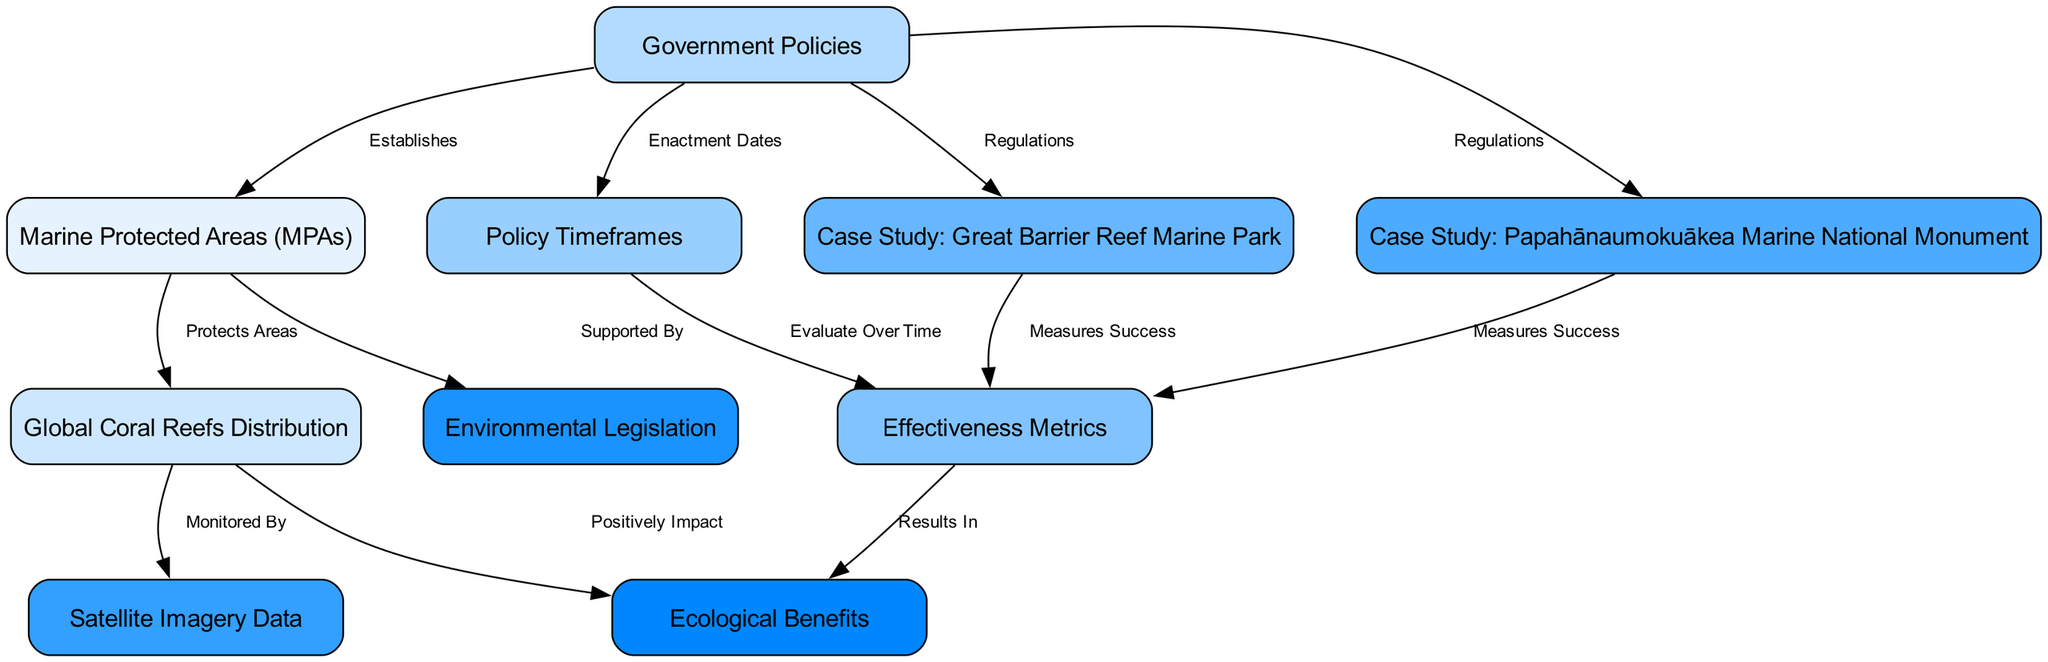What is the primary focus of the diagram? The diagram primarily focuses on the relationship between marine protected areas (MPAs) and various factors related to their effectiveness in coral reef preservation, specifically highlighting government policies and their historical analysis.
Answer: Marine Protected Areas (MPAs) How many nodes are present in the diagram? Counting the unique entities represented, there are a total of 10 nodes in the diagram, each related to various aspects of marine protection and coral reefs.
Answer: 10 Which node is connected to both the Government Policies and Policy Timeframes? The node titled Policy Timeframes directly connects to the Government Policies, indicating that policies have specific enactment dates or timelines associated with them.
Answer: Policy Timeframes What do Marine Protected Areas (MPAs) protect? According to the diagram, Marine Protected Areas (MPAs) protect global coral reefs distribution, indicating their role in conserving these essential ecosystems.
Answer: Global Coral Reefs Distribution What type of data monitors coral reefs according to the diagram? The diagram states that satellite imagery data is used to monitor global coral reefs distribution, providing essential insights into their health and status.
Answer: Satellite Imagery Data Which case study is linked to the effectiveness metrics? The diagram shows that both case studies, the Great Barrier Reef Marine Park and the Papahānaumokuākea Marine National Monument, are linked to effectiveness metrics, focusing on measuring success of regulations.
Answer: Great Barrier Reef Marine Park and Papahānaumokuākea Marine National Monument What is the relationship between Effectiveness Metrics and Ecological Benefits? Effectiveness metrics, as shown in the diagram, lead to ecological benefits, indicating that evaluating the success of government policies results in positive impacts on coral ecosystems.
Answer: Results In How do government policies relate to marine protected areas? The diagram illustrates that government policies establish Marine Protected Areas (MPAs), indicating that these policies play a vital role in creating protected zones for marine ecosystems.
Answer: Establishes What is the connection between Environmental Legislation and Marine Protected Areas (MPAs)? Environmental legislation supports marine protected areas (MPAs) in the diagram, suggesting that legal frameworks are crucial for the establishment and maintenance of these protective zones.
Answer: Supported By Which metric is evaluated over time according to the diagram? The diagram indicates that effectiveness metrics are evaluated over time, which emphasizes the need for continuous assessment of policies relating to marine protected areas.
Answer: Effectiveness Metrics 